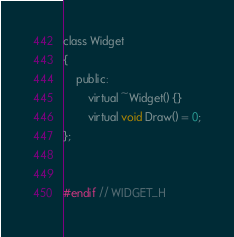Convert code to text. <code><loc_0><loc_0><loc_500><loc_500><_C_>class Widget
{
    public:
        virtual ~Widget() {}
        virtual void Draw() = 0;
};


#endif // WIDGET_H
</code> 